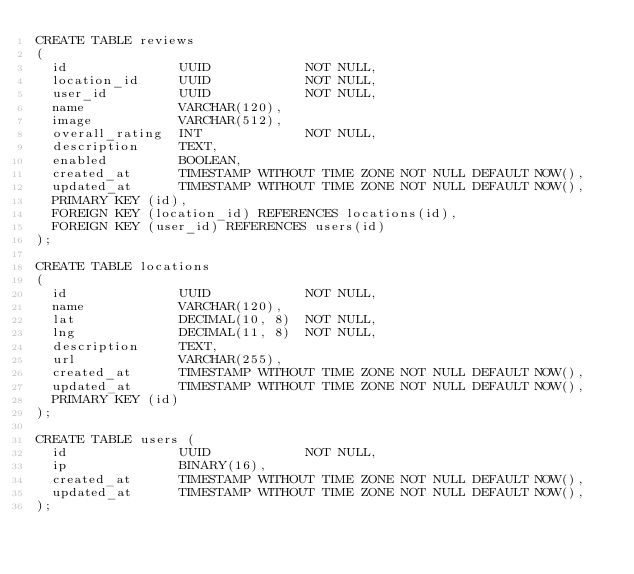Convert code to text. <code><loc_0><loc_0><loc_500><loc_500><_SQL_>CREATE TABLE reviews
(
  id              UUID            NOT NULL,
  location_id     UUID            NOT NULL,
  user_id         UUID            NOT NULL,
  name            VARCHAR(120),
  image           VARCHAR(512),
  overall_rating  INT             NOT NULL,
  description     TEXT,
  enabled         BOOLEAN,
  created_at      TIMESTAMP WITHOUT TIME ZONE NOT NULL DEFAULT NOW(),
  updated_at      TIMESTAMP WITHOUT TIME ZONE NOT NULL DEFAULT NOW(),
  PRIMARY KEY (id),
  FOREIGN KEY (location_id) REFERENCES locations(id),
  FOREIGN KEY (user_id) REFERENCES users(id)
);

CREATE TABLE locations
(
  id              UUID            NOT NULL,
  name            VARCHAR(120),
  lat             DECIMAL(10, 8)  NOT NULL,
  lng             DECIMAL(11, 8)  NOT NULL,
  description     TEXT,
  url             VARCHAR(255),
  created_at      TIMESTAMP WITHOUT TIME ZONE NOT NULL DEFAULT NOW(),
  updated_at      TIMESTAMP WITHOUT TIME ZONE NOT NULL DEFAULT NOW(),
  PRIMARY KEY (id)
);

CREATE TABLE users (
  id              UUID            NOT NULL,
  ip              BINARY(16),
  created_at      TIMESTAMP WITHOUT TIME ZONE NOT NULL DEFAULT NOW(),
  updated_at      TIMESTAMP WITHOUT TIME ZONE NOT NULL DEFAULT NOW(),
);
</code> 